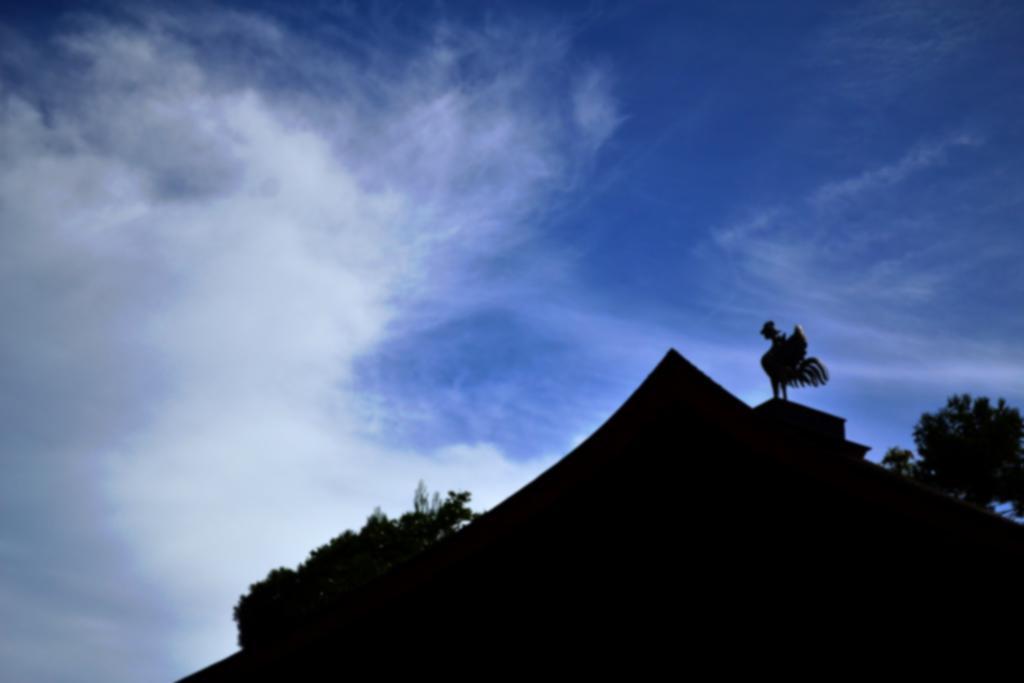Please provide a concise description of this image. In this image I can see few trees, clouds, the sky and here I can see black colour thing. I can also see this image is little bit in dark from here. 